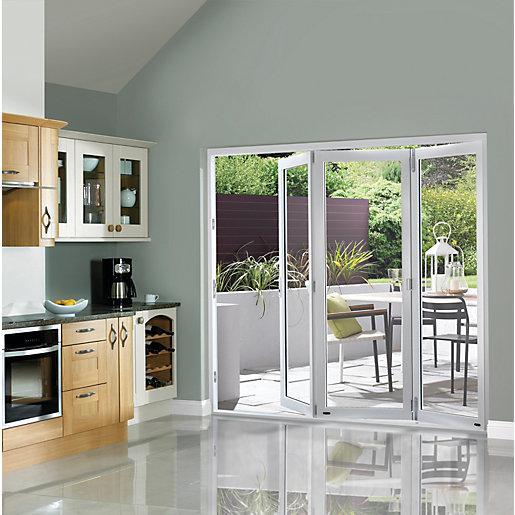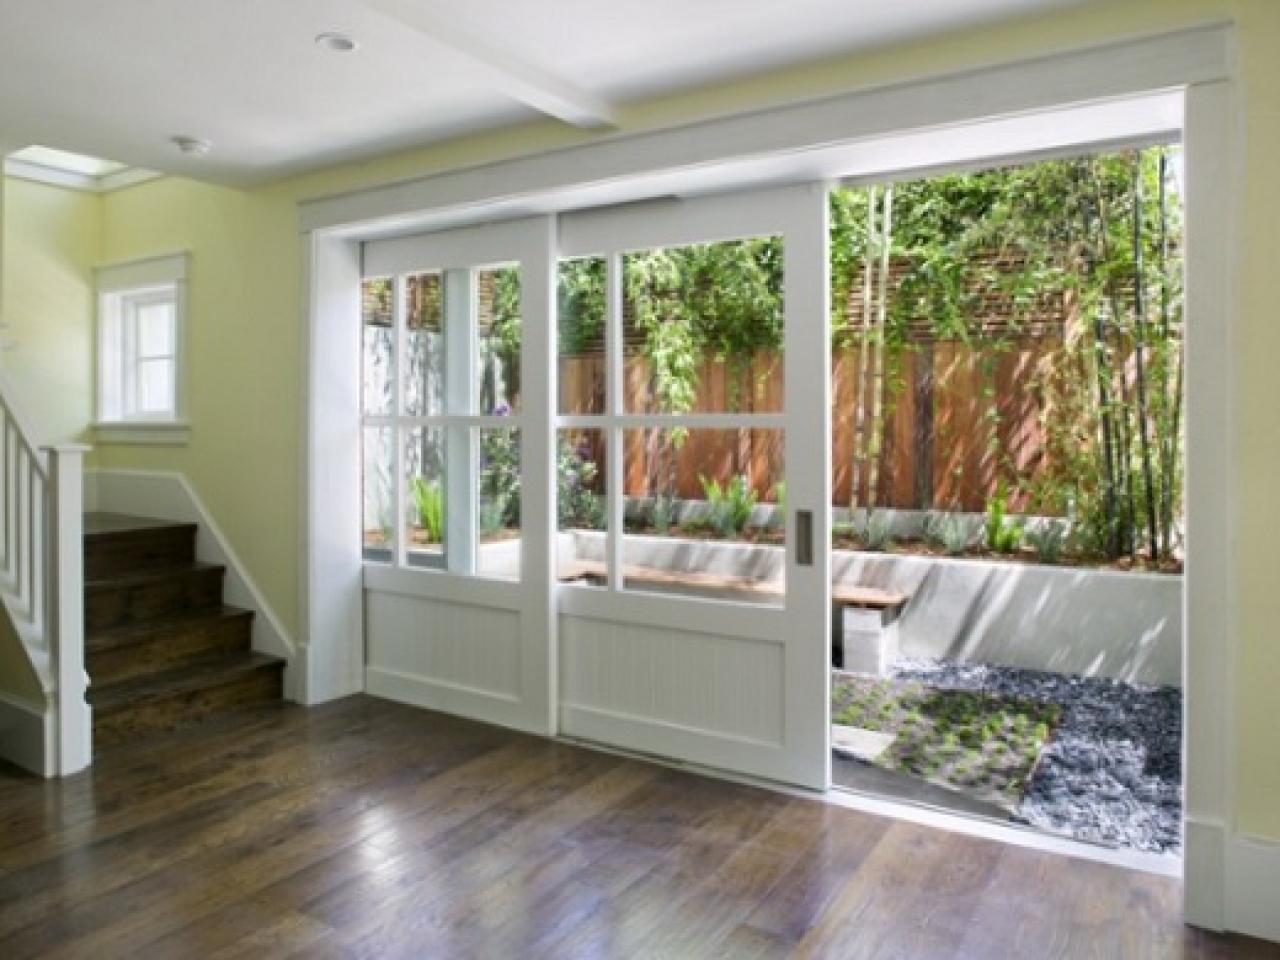The first image is the image on the left, the second image is the image on the right. Assess this claim about the two images: "An image shows a room with accordion-type sliding doors that are at least partly open, revealing a room-length view of natural scenery.". Correct or not? Answer yes or no. No. The first image is the image on the left, the second image is the image on the right. Considering the images on both sides, is "In at least one image there is a six parily open glass door panels attached to each other." valid? Answer yes or no. No. 